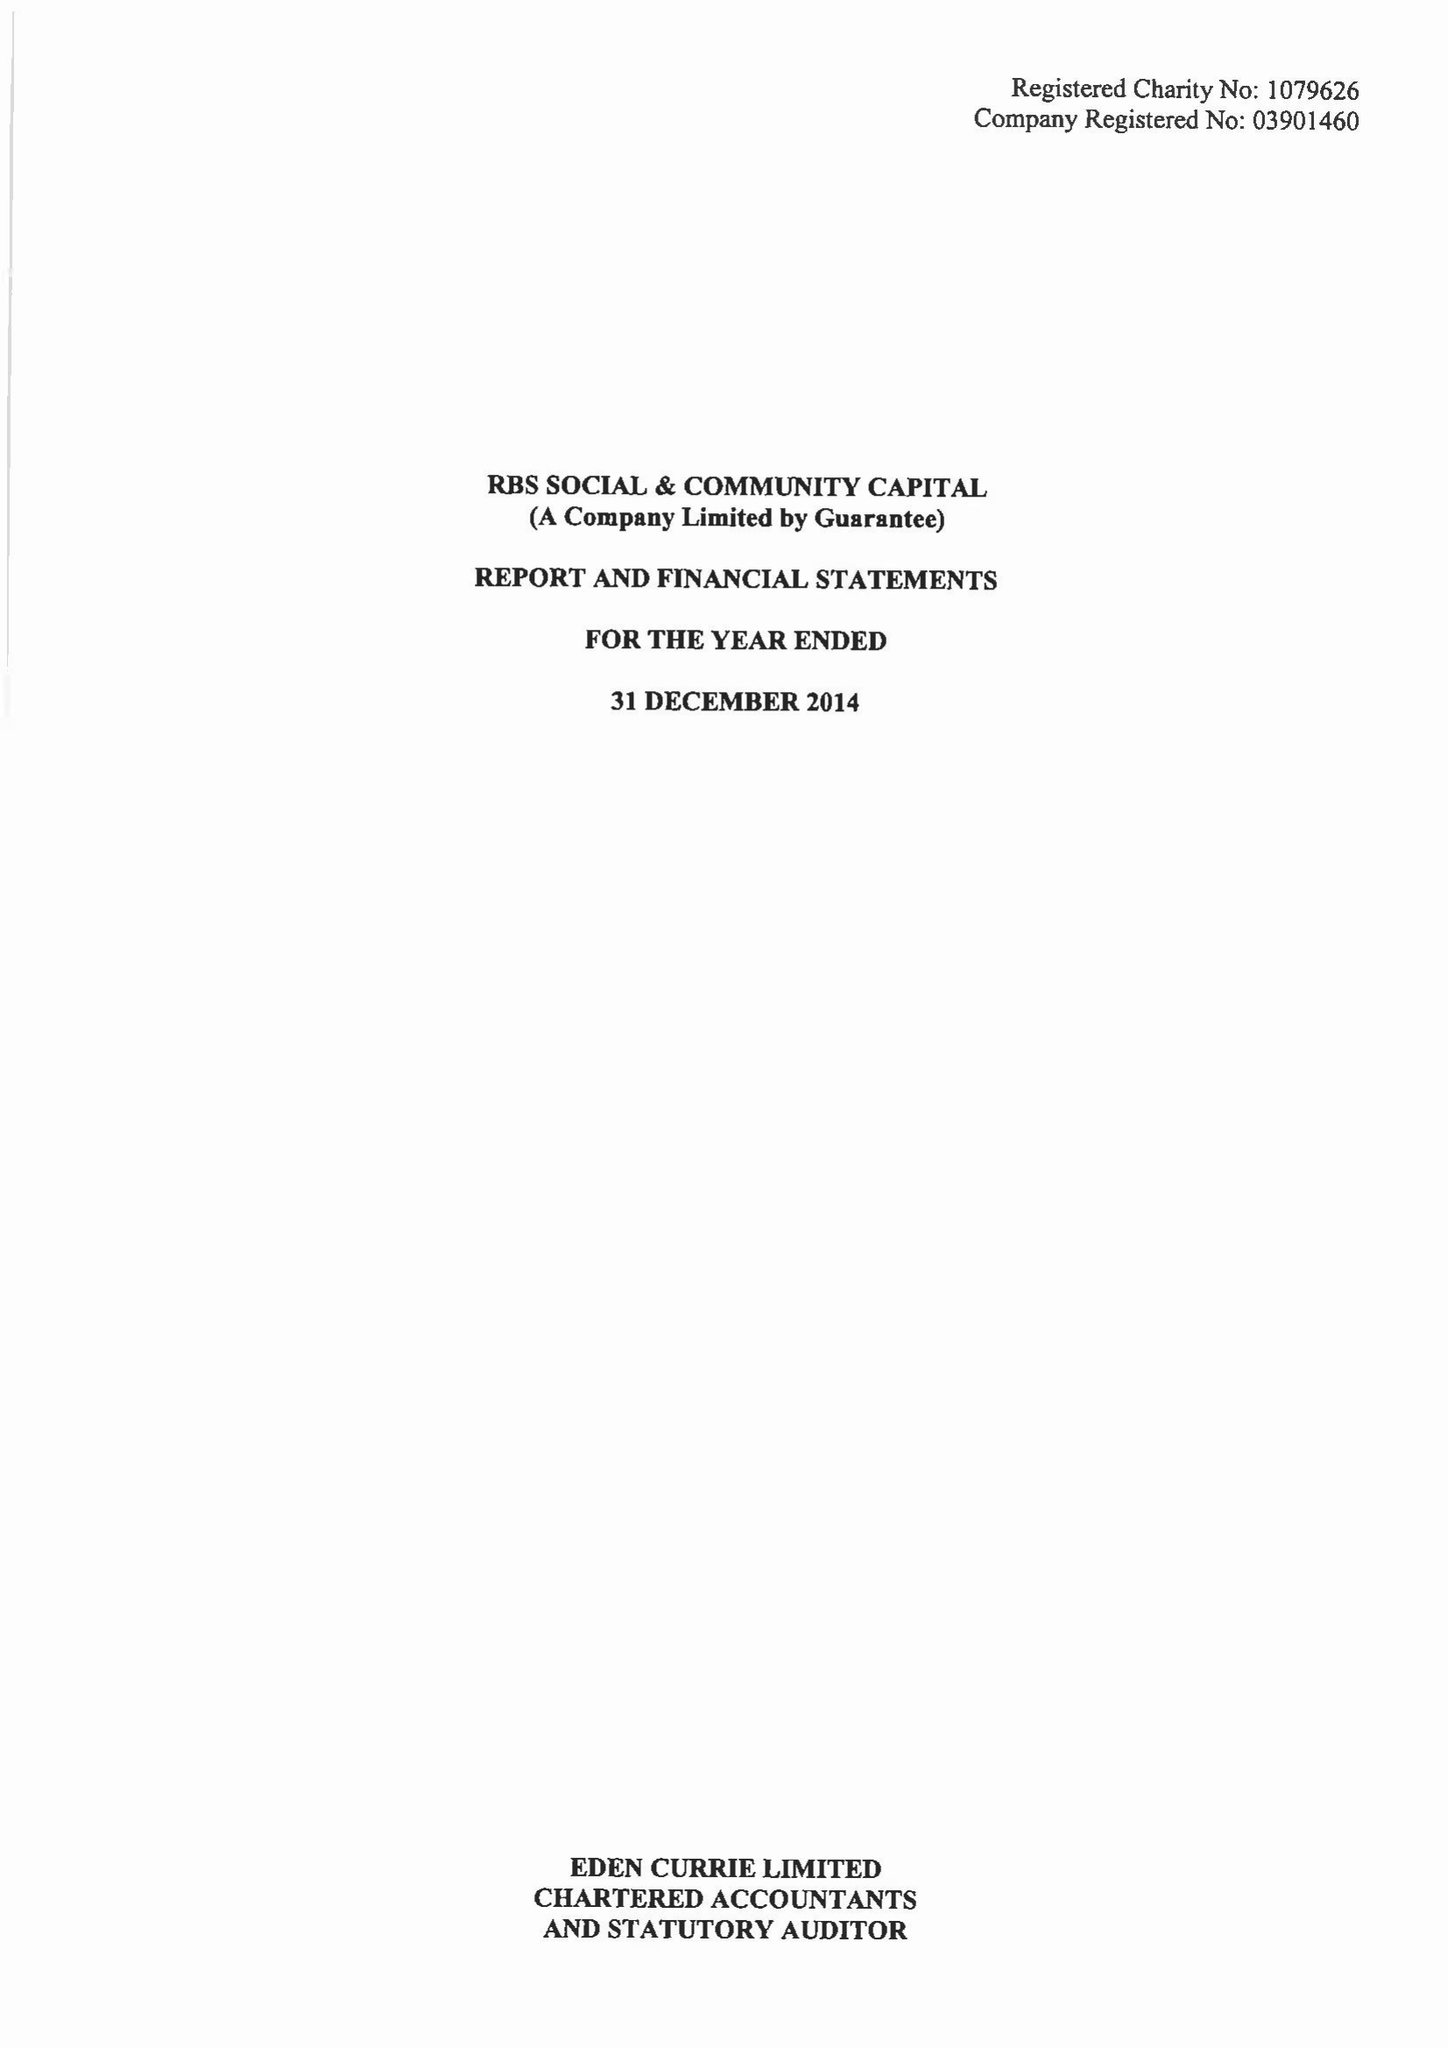What is the value for the spending_annually_in_british_pounds?
Answer the question using a single word or phrase. 722276.00 